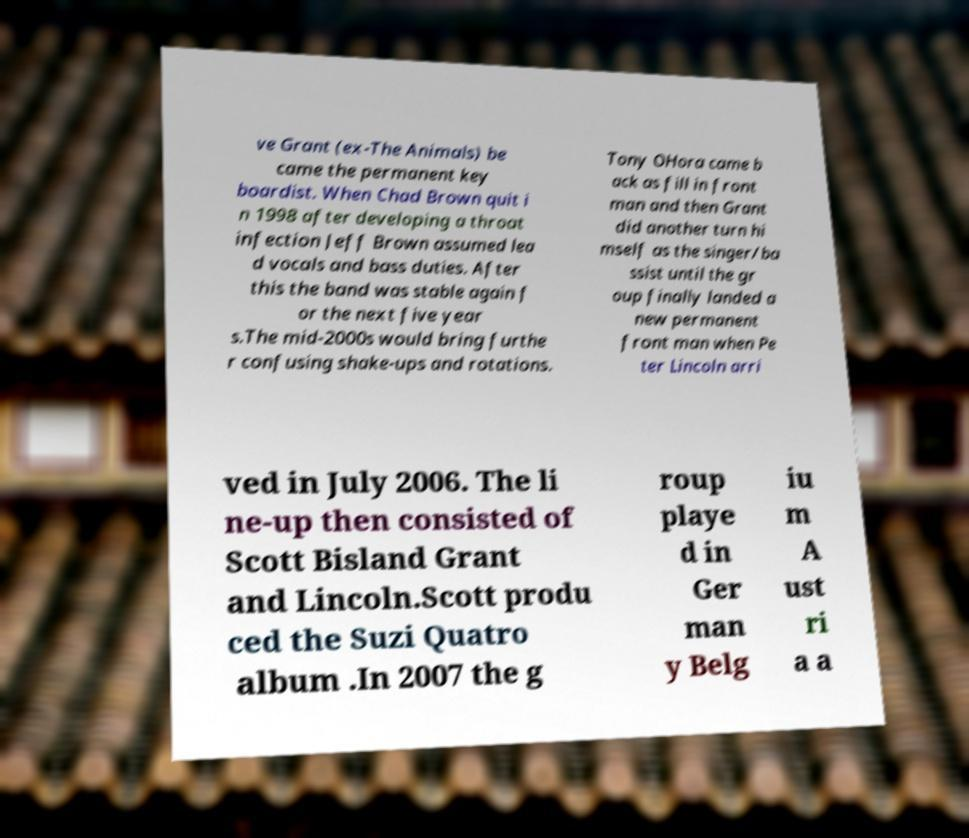Can you accurately transcribe the text from the provided image for me? ve Grant (ex-The Animals) be came the permanent key boardist. When Chad Brown quit i n 1998 after developing a throat infection Jeff Brown assumed lea d vocals and bass duties. After this the band was stable again f or the next five year s.The mid-2000s would bring furthe r confusing shake-ups and rotations. Tony OHora came b ack as fill in front man and then Grant did another turn hi mself as the singer/ba ssist until the gr oup finally landed a new permanent front man when Pe ter Lincoln arri ved in July 2006. The li ne-up then consisted of Scott Bisland Grant and Lincoln.Scott produ ced the Suzi Quatro album .In 2007 the g roup playe d in Ger man y Belg iu m A ust ri a a 